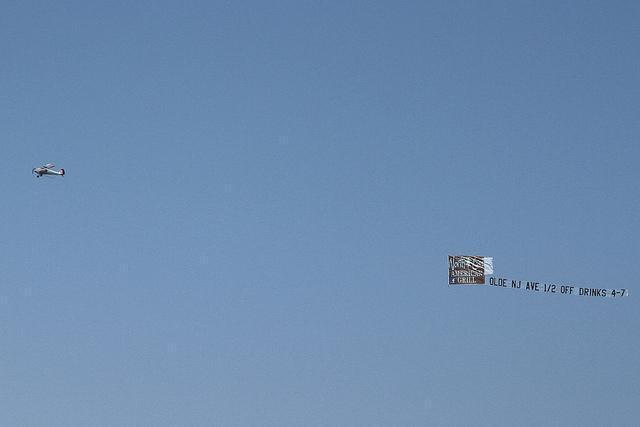How many signs is the plane pulling?
Give a very brief answer. 1. 